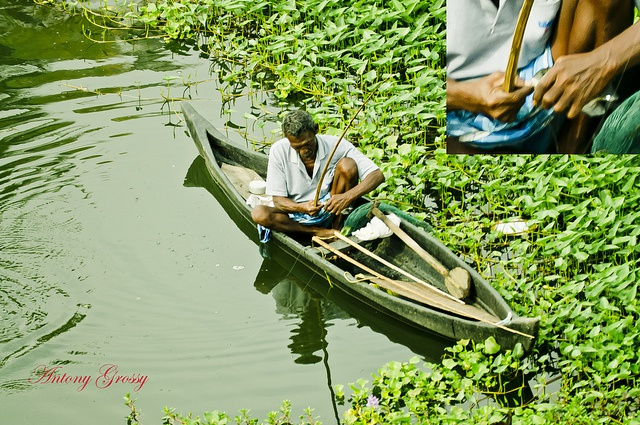Describe the objects in this image and their specific colors. I can see people in darkgreen, black, lightgray, tan, and olive tones, boat in darkgreen, black, khaki, and olive tones, and people in darkgreen, lightgray, black, olive, and darkgray tones in this image. 